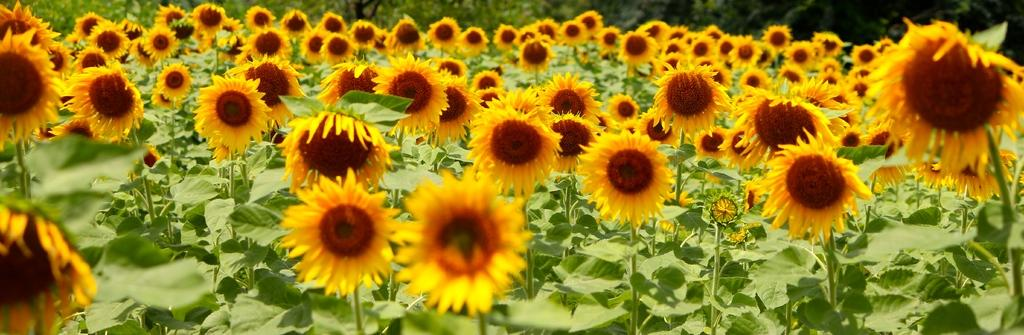What type of living organisms can be seen in the image? Plants and flowers are visible in the image. Can you describe the flowers in the image? The flowers in the image are part of the plants and add color and beauty to the scene. What type of cream is being used to cook the stew in the image? There is no cream or stew present in the image; it features plants and flowers. How many planes can be seen flying over the plants in the image? There are no planes visible in the image; it only contains plants and flowers. 